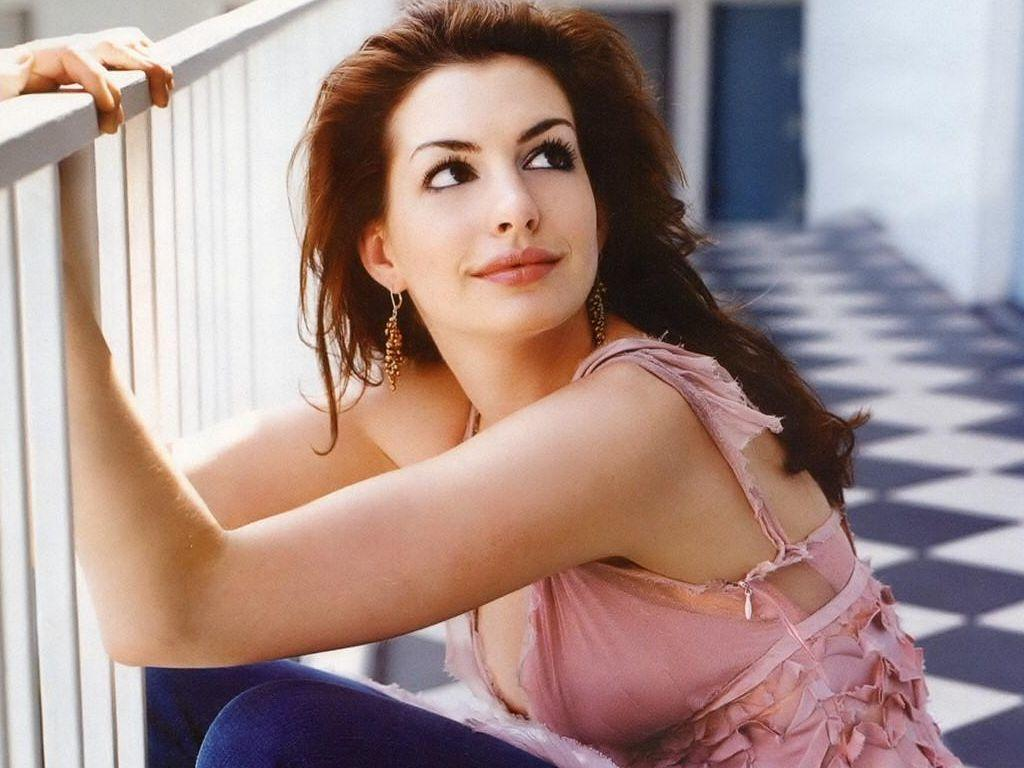Who is present in the image? There is a woman in the image. What is the woman wearing? The woman is wearing a shirt and jeans. What is the woman's facial expression? The woman is smiling. Where is the woman sitting in relation to the fencing? The woman is sitting near fencing. What can be seen in the top right corner of the image? There is a wall visible in the top right of the image. What type of authority does the woman represent in the image? There is no indication in the image that the woman represents any authority. 